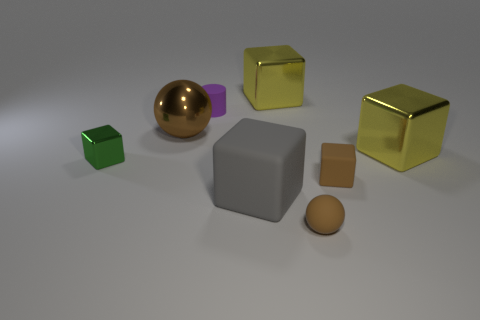What kind of material do the objects seem to be made from? The objects exhibit various textures and sheens that suggest they are made from metallic and matte materials. 